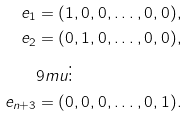Convert formula to latex. <formula><loc_0><loc_0><loc_500><loc_500>e _ { 1 } & = ( 1 , 0 , 0 , \dots , 0 , 0 ) , \\ e _ { 2 } & = ( 0 , 1 , 0 , \dots , 0 , 0 ) , \\ & { 9 m u } \vdots \\ e _ { n + 3 } & = ( 0 , 0 , 0 , \dots , 0 , 1 ) .</formula> 